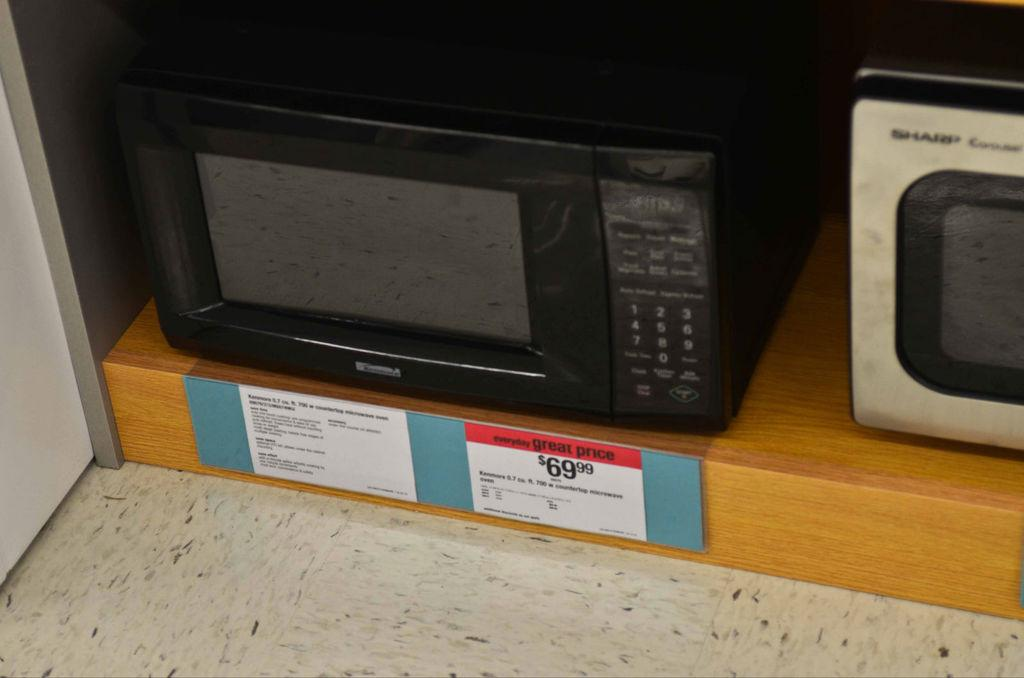Provide a one-sentence caption for the provided image. old black colored  microwave oven placed in a rack with the price listing $6999. 